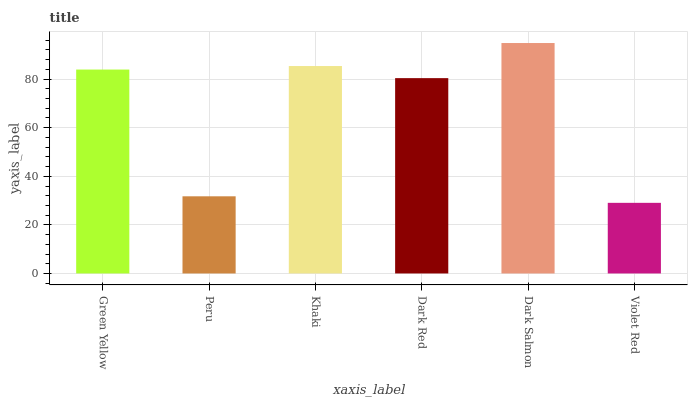Is Violet Red the minimum?
Answer yes or no. Yes. Is Dark Salmon the maximum?
Answer yes or no. Yes. Is Peru the minimum?
Answer yes or no. No. Is Peru the maximum?
Answer yes or no. No. Is Green Yellow greater than Peru?
Answer yes or no. Yes. Is Peru less than Green Yellow?
Answer yes or no. Yes. Is Peru greater than Green Yellow?
Answer yes or no. No. Is Green Yellow less than Peru?
Answer yes or no. No. Is Green Yellow the high median?
Answer yes or no. Yes. Is Dark Red the low median?
Answer yes or no. Yes. Is Dark Red the high median?
Answer yes or no. No. Is Dark Salmon the low median?
Answer yes or no. No. 